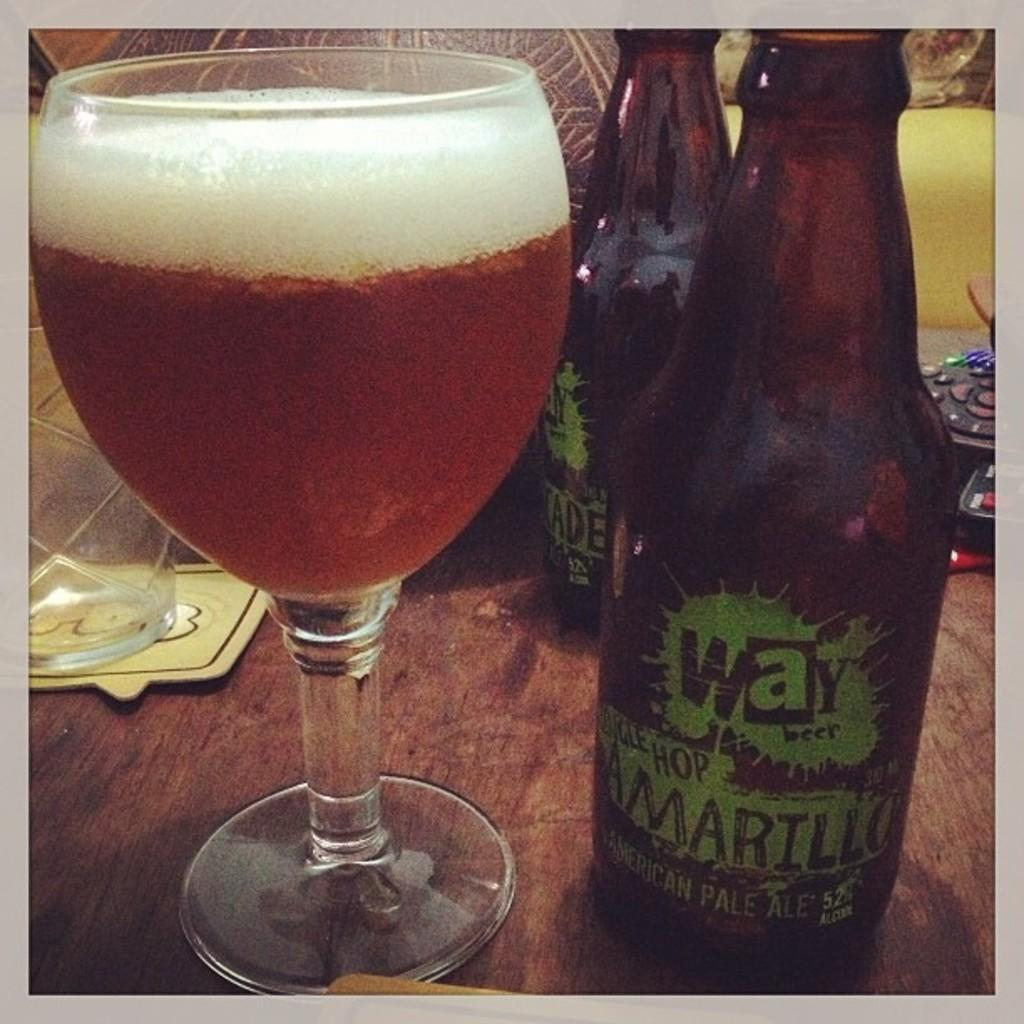Provide a one-sentence caption for the provided image. A bottle of beer from Way Beer titled Amarillo sits on a table next to a glass of poured beer. 